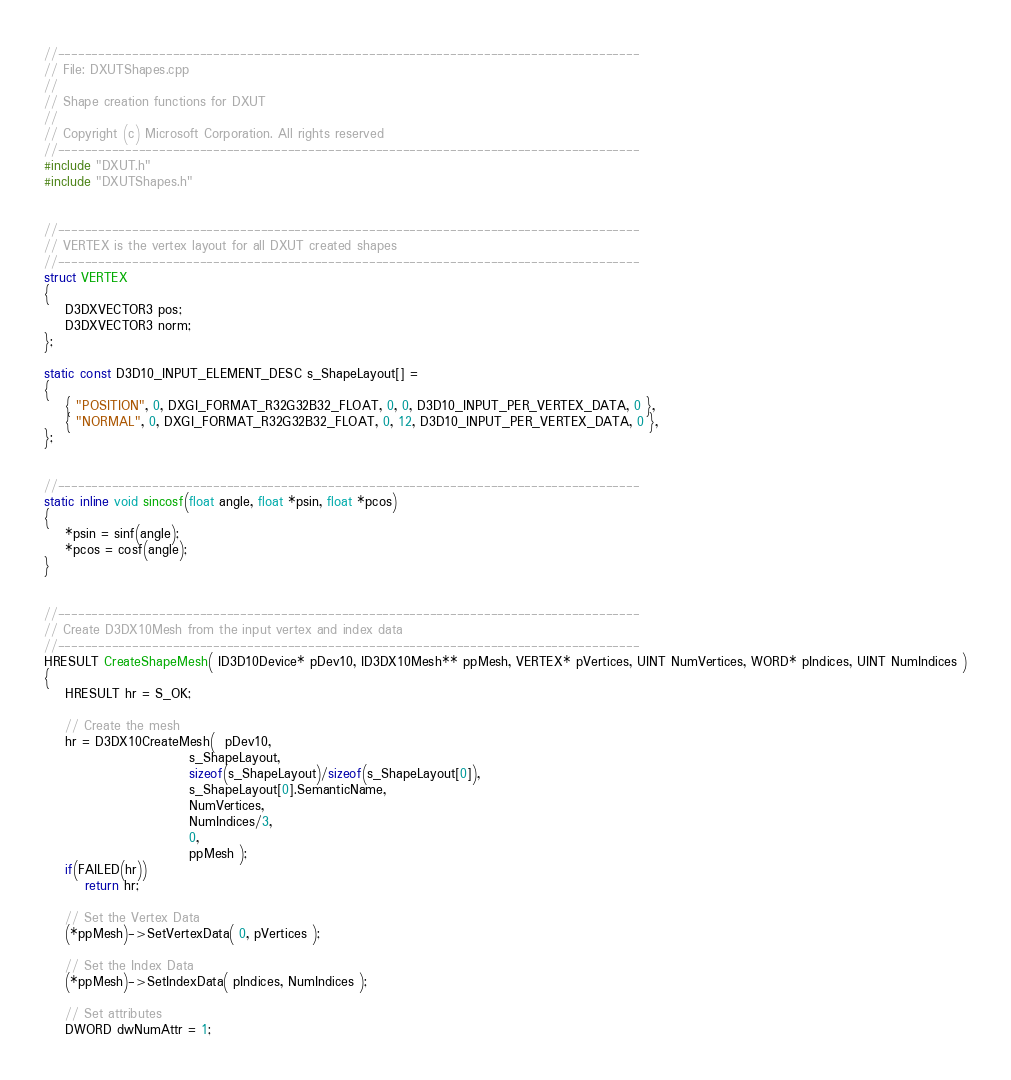Convert code to text. <code><loc_0><loc_0><loc_500><loc_500><_C++_>//--------------------------------------------------------------------------------------
// File: DXUTShapes.cpp
//
// Shape creation functions for DXUT
//
// Copyright (c) Microsoft Corporation. All rights reserved
//--------------------------------------------------------------------------------------
#include "DXUT.h"
#include "DXUTShapes.h"


//--------------------------------------------------------------------------------------
// VERTEX is the vertex layout for all DXUT created shapes
//--------------------------------------------------------------------------------------
struct VERTEX
{
    D3DXVECTOR3 pos;
    D3DXVECTOR3 norm;
};

static const D3D10_INPUT_ELEMENT_DESC s_ShapeLayout[] =
{
    { "POSITION", 0, DXGI_FORMAT_R32G32B32_FLOAT, 0, 0, D3D10_INPUT_PER_VERTEX_DATA, 0 },
    { "NORMAL", 0, DXGI_FORMAT_R32G32B32_FLOAT, 0, 12, D3D10_INPUT_PER_VERTEX_DATA, 0 },
};


//--------------------------------------------------------------------------------------
static inline void sincosf(float angle, float *psin, float *pcos)
{
    *psin = sinf(angle);
    *pcos = cosf(angle);
}


//--------------------------------------------------------------------------------------
// Create D3DX10Mesh from the input vertex and index data
//--------------------------------------------------------------------------------------
HRESULT CreateShapeMesh( ID3D10Device* pDev10, ID3DX10Mesh** ppMesh, VERTEX* pVertices, UINT NumVertices, WORD* pIndices, UINT NumIndices )
{
    HRESULT hr = S_OK;

    // Create the mesh 
    hr = D3DX10CreateMesh(  pDev10,
                            s_ShapeLayout, 
                            sizeof(s_ShapeLayout)/sizeof(s_ShapeLayout[0]),
                            s_ShapeLayout[0].SemanticName,
                            NumVertices,
                            NumIndices/3,
                            0, 
                            ppMesh );
    if(FAILED(hr))
        return hr;

    // Set the Vertex Data
    (*ppMesh)->SetVertexData( 0, pVertices );

    // Set the Index Data
    (*ppMesh)->SetIndexData( pIndices, NumIndices );

    // Set attributes
    DWORD dwNumAttr = 1;</code> 